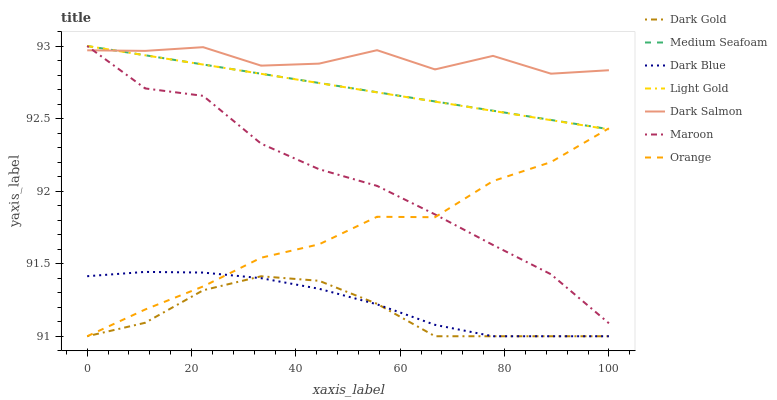Does Maroon have the minimum area under the curve?
Answer yes or no. No. Does Maroon have the maximum area under the curve?
Answer yes or no. No. Is Maroon the smoothest?
Answer yes or no. No. Is Maroon the roughest?
Answer yes or no. No. Does Maroon have the lowest value?
Answer yes or no. No. Does Dark Salmon have the highest value?
Answer yes or no. No. Is Dark Gold less than Light Gold?
Answer yes or no. Yes. Is Dark Salmon greater than Dark Gold?
Answer yes or no. Yes. Does Dark Gold intersect Light Gold?
Answer yes or no. No. 